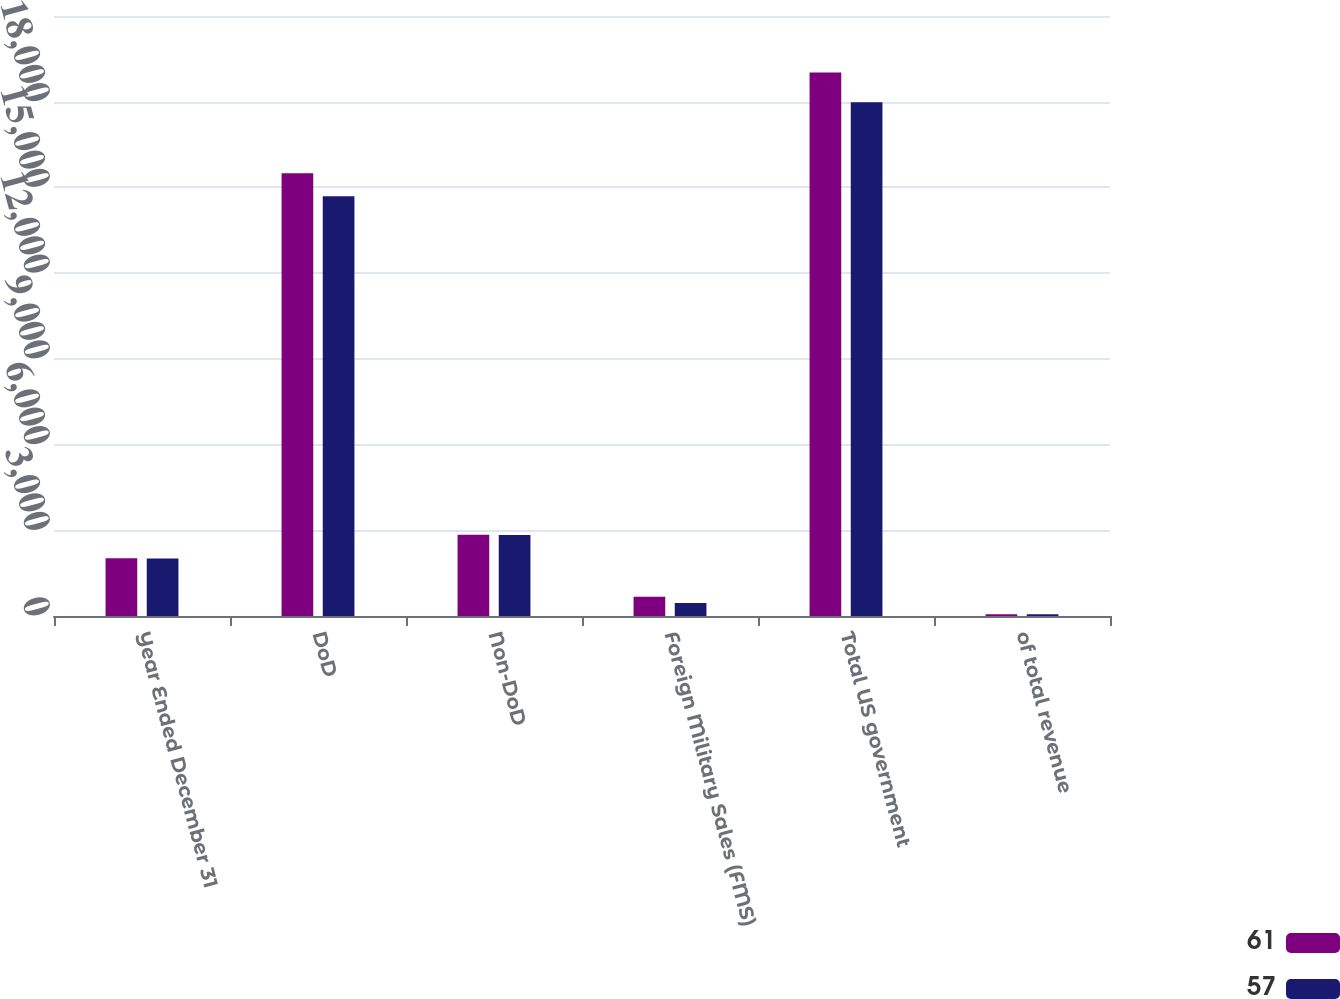Convert chart. <chart><loc_0><loc_0><loc_500><loc_500><stacked_bar_chart><ecel><fcel>Year Ended December 31<fcel>DoD<fcel>Non-DoD<fcel>Foreign Military Sales (FMS)<fcel>Total US government<fcel>of total revenue<nl><fcel>61<fcel>2017<fcel>15498<fcel>2847<fcel>676<fcel>19021<fcel>61<nl><fcel>57<fcel>2015<fcel>14694<fcel>2831<fcel>453<fcel>17978<fcel>57<nl></chart> 